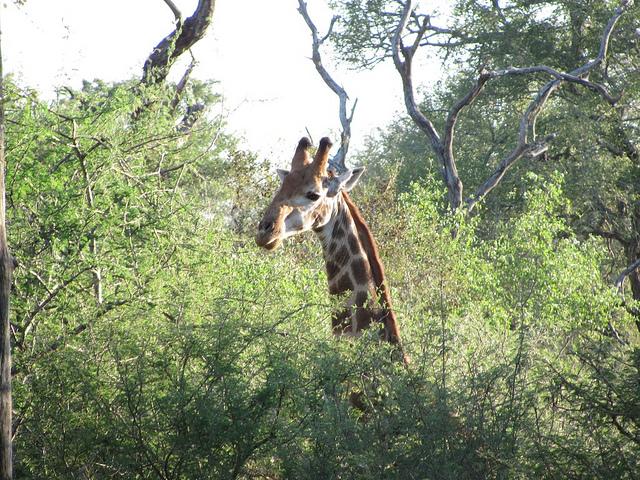What type of animal is this?
Give a very brief answer. Giraffe. How many giraffes are in this picture?
Answer briefly. 1. Is the giraffe drinking water or eating?
Quick response, please. Neither. Is the giraffe grazing?
Give a very brief answer. Yes. Is this giraffe in the wild?
Give a very brief answer. Yes. 